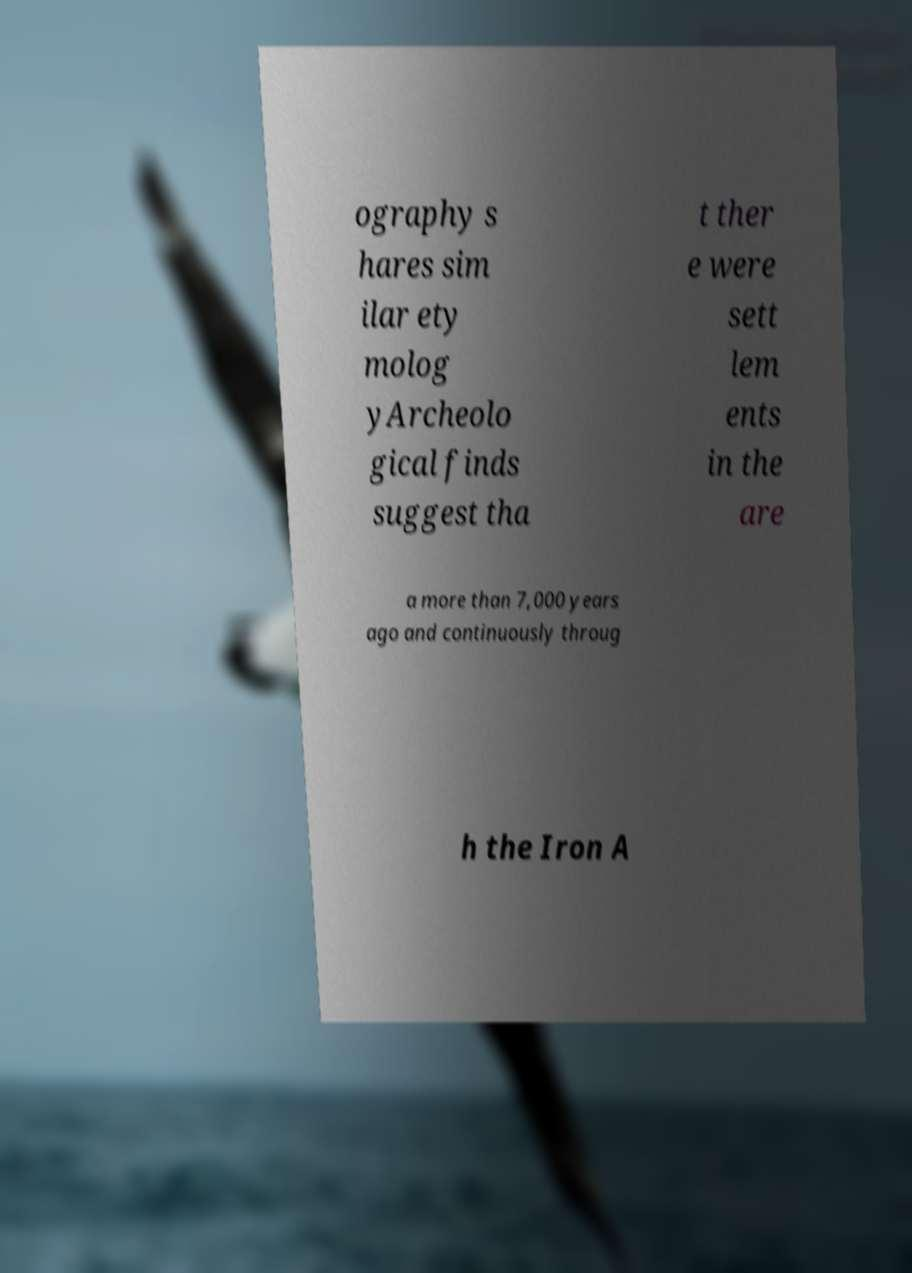What messages or text are displayed in this image? I need them in a readable, typed format. ography s hares sim ilar ety molog yArcheolo gical finds suggest tha t ther e were sett lem ents in the are a more than 7,000 years ago and continuously throug h the Iron A 